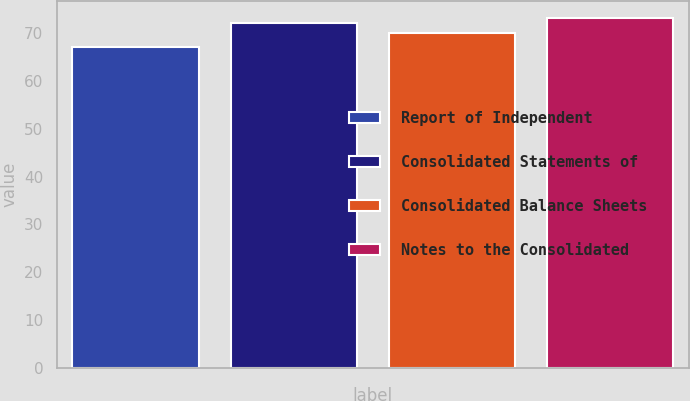<chart> <loc_0><loc_0><loc_500><loc_500><bar_chart><fcel>Report of Independent<fcel>Consolidated Statements of<fcel>Consolidated Balance Sheets<fcel>Notes to the Consolidated<nl><fcel>67<fcel>72<fcel>70<fcel>73<nl></chart> 